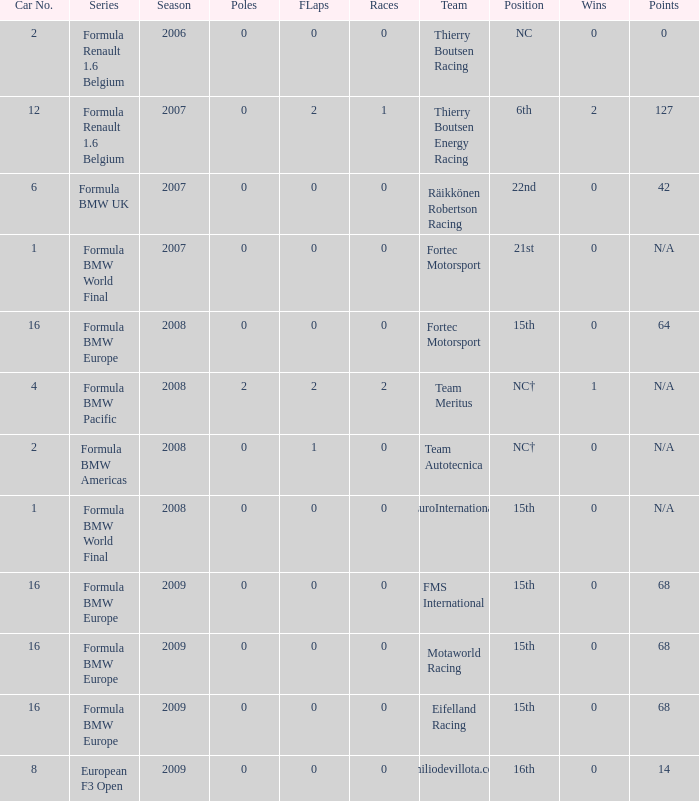Name the series for 68 Formula BMW Europe, Formula BMW Europe, Formula BMW Europe. 